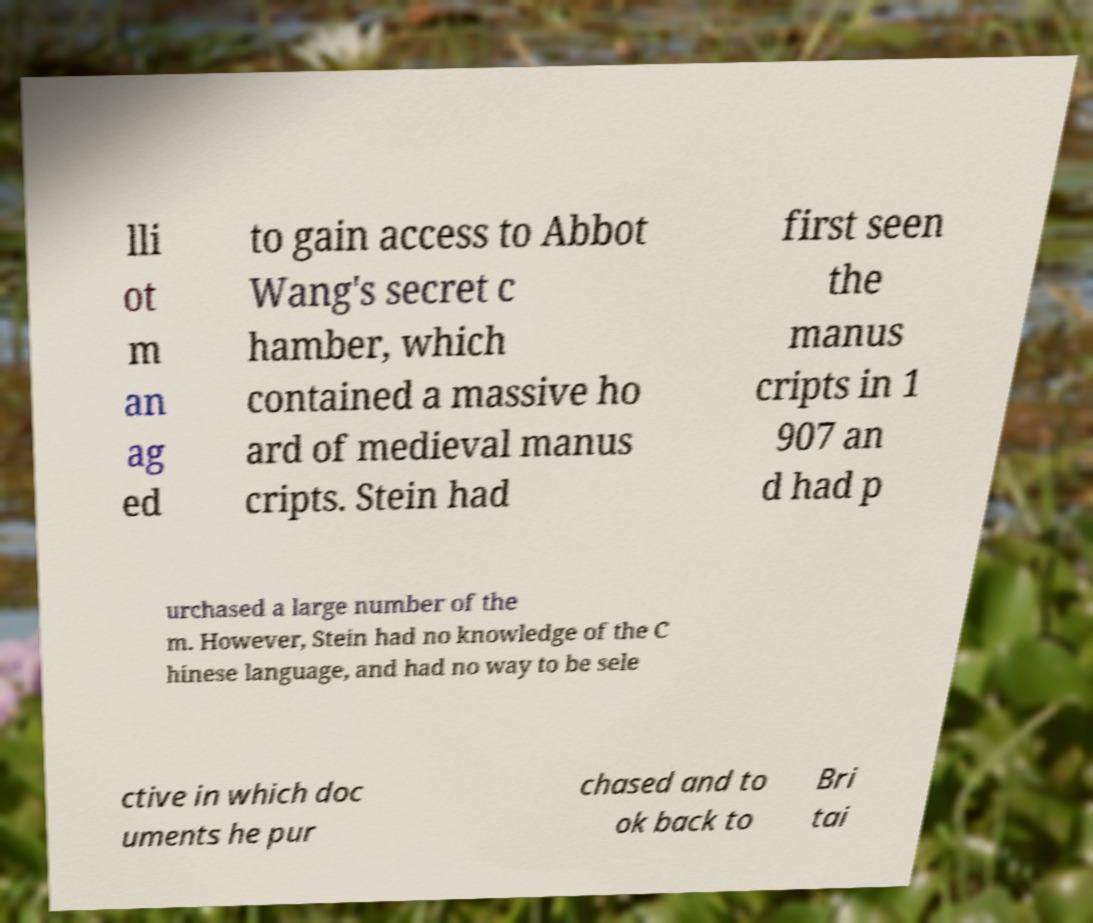I need the written content from this picture converted into text. Can you do that? lli ot m an ag ed to gain access to Abbot Wang's secret c hamber, which contained a massive ho ard of medieval manus cripts. Stein had first seen the manus cripts in 1 907 an d had p urchased a large number of the m. However, Stein had no knowledge of the C hinese language, and had no way to be sele ctive in which doc uments he pur chased and to ok back to Bri tai 